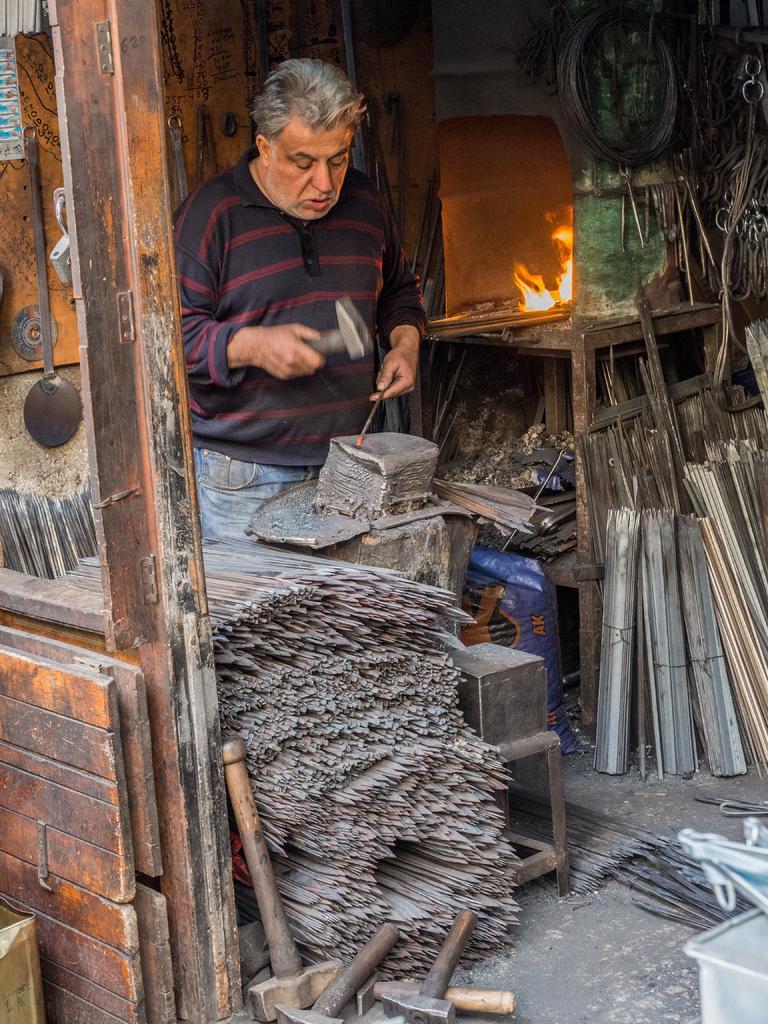Please provide a concise description of this image. In this image we can see there is a person standing and holding a hammer and on the other hand he is holding an object and trying to hit. On the floor there are few objects and a few hammers placed. On the right side of the image there is a fire and some other objects placed on the table and some equipment hanging on the wooden board behind the person. 